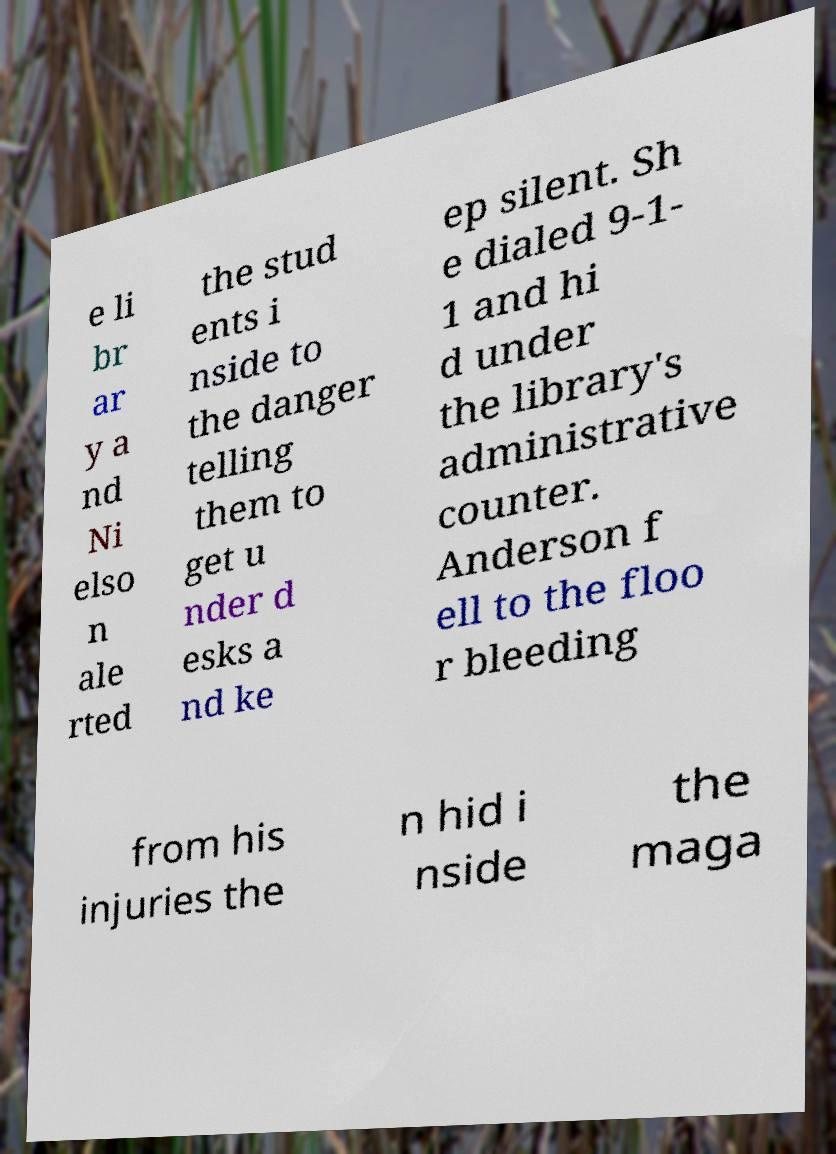I need the written content from this picture converted into text. Can you do that? e li br ar y a nd Ni elso n ale rted the stud ents i nside to the danger telling them to get u nder d esks a nd ke ep silent. Sh e dialed 9-1- 1 and hi d under the library's administrative counter. Anderson f ell to the floo r bleeding from his injuries the n hid i nside the maga 